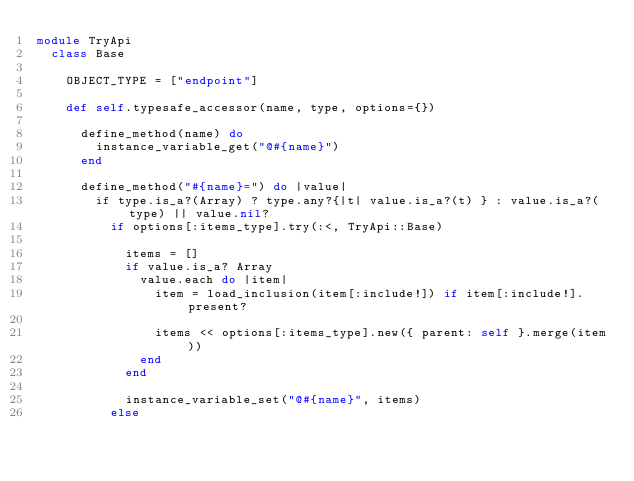Convert code to text. <code><loc_0><loc_0><loc_500><loc_500><_Ruby_>module TryApi
  class Base

    OBJECT_TYPE = ["endpoint"]

    def self.typesafe_accessor(name, type, options={})

      define_method(name) do
        instance_variable_get("@#{name}")
      end

      define_method("#{name}=") do |value|
        if type.is_a?(Array) ? type.any?{|t| value.is_a?(t) } : value.is_a?(type) || value.nil?
          if options[:items_type].try(:<, TryApi::Base)

            items = []
            if value.is_a? Array
              value.each do |item|
                item = load_inclusion(item[:include!]) if item[:include!].present?

                items << options[:items_type].new({ parent: self }.merge(item))
              end
            end

            instance_variable_set("@#{name}", items)
          else</code> 